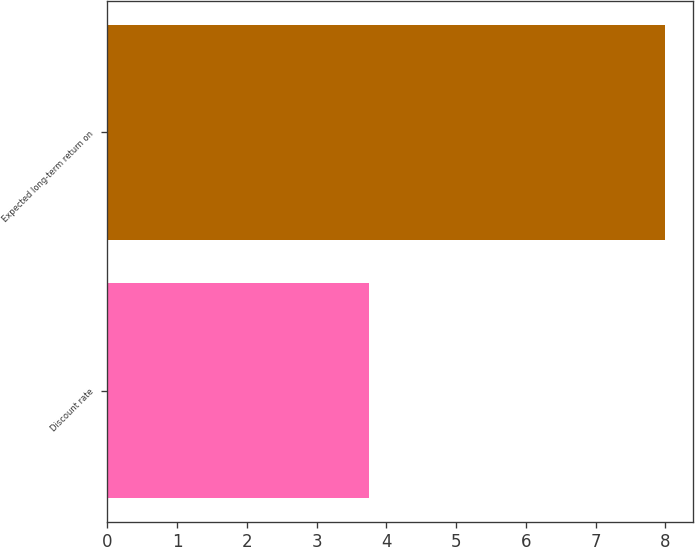<chart> <loc_0><loc_0><loc_500><loc_500><bar_chart><fcel>Discount rate<fcel>Expected long-term return on<nl><fcel>3.75<fcel>8<nl></chart> 